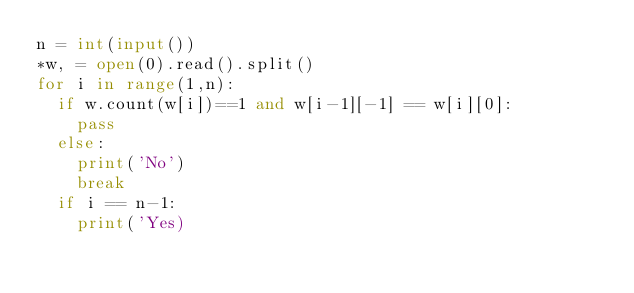Convert code to text. <code><loc_0><loc_0><loc_500><loc_500><_Python_>n = int(input())
*w, = open(0).read().split()
for i in range(1,n):
  if w.count(w[i])==1 and w[i-1][-1] == w[i][0]:
    pass
  else:
    print('No')
    break
  if i == n-1:
    print('Yes)</code> 